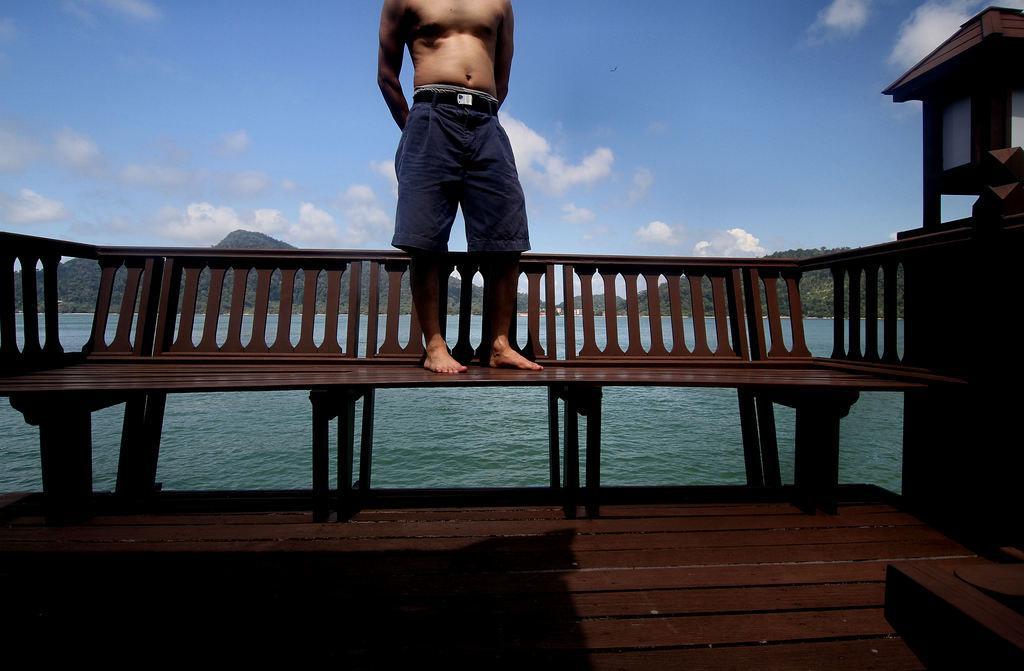Please provide a concise description of this image. Here in this picture we can see a person standing on a bench present over there and behind him we can see water present all over there and in the far we can see mountains that are covered with grass and plants present over there and we can see clouds in the sky over there. 